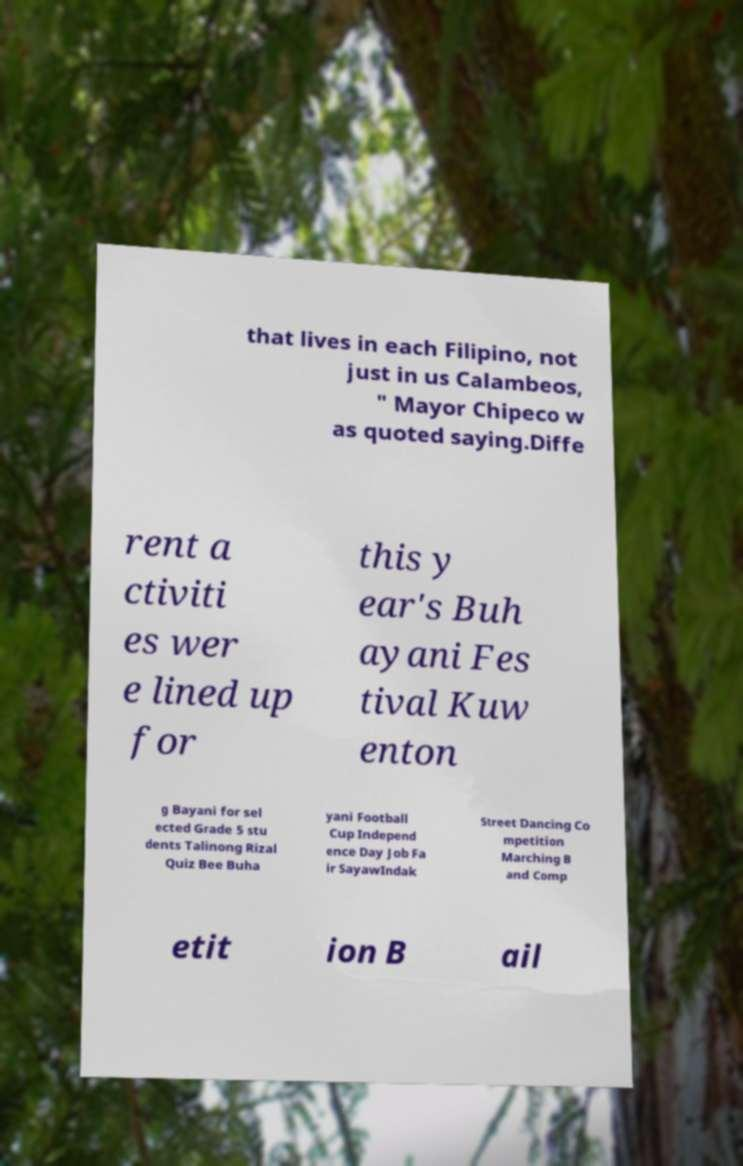There's text embedded in this image that I need extracted. Can you transcribe it verbatim? that lives in each Filipino, not just in us Calambeos, " Mayor Chipeco w as quoted saying.Diffe rent a ctiviti es wer e lined up for this y ear's Buh ayani Fes tival Kuw enton g Bayani for sel ected Grade 5 stu dents Talinong Rizal Quiz Bee Buha yani Football Cup Independ ence Day Job Fa ir SayawIndak Street Dancing Co mpetition Marching B and Comp etit ion B ail 